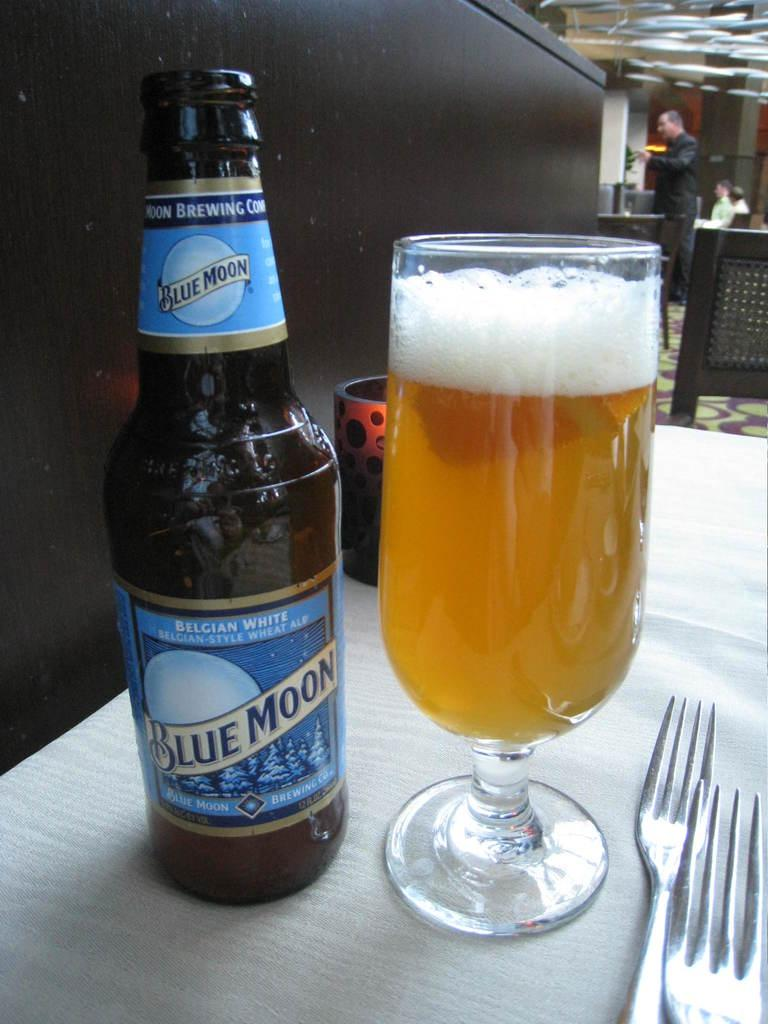<image>
Write a terse but informative summary of the picture. a bottle of belgian white blue moon next to a glass filled of it 